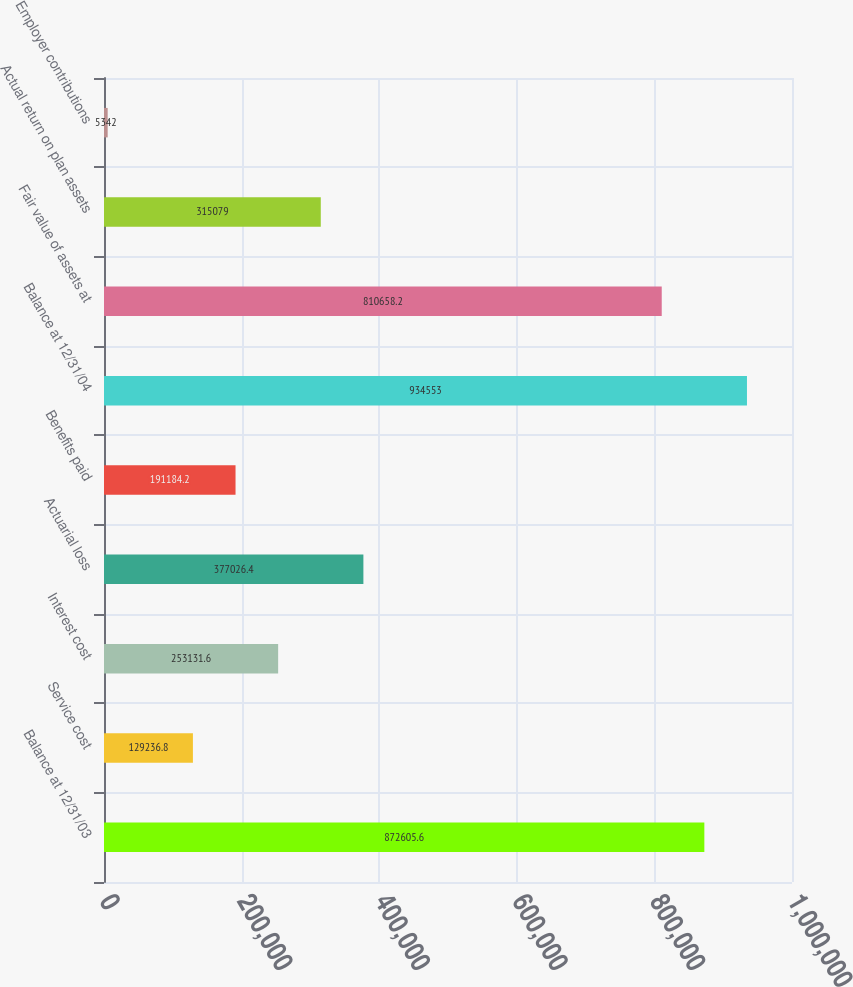Convert chart. <chart><loc_0><loc_0><loc_500><loc_500><bar_chart><fcel>Balance at 12/31/03<fcel>Service cost<fcel>Interest cost<fcel>Actuarial loss<fcel>Benefits paid<fcel>Balance at 12/31/04<fcel>Fair value of assets at<fcel>Actual return on plan assets<fcel>Employer contributions<nl><fcel>872606<fcel>129237<fcel>253132<fcel>377026<fcel>191184<fcel>934553<fcel>810658<fcel>315079<fcel>5342<nl></chart> 